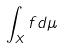<formula> <loc_0><loc_0><loc_500><loc_500>\int _ { X } f d \mu</formula> 